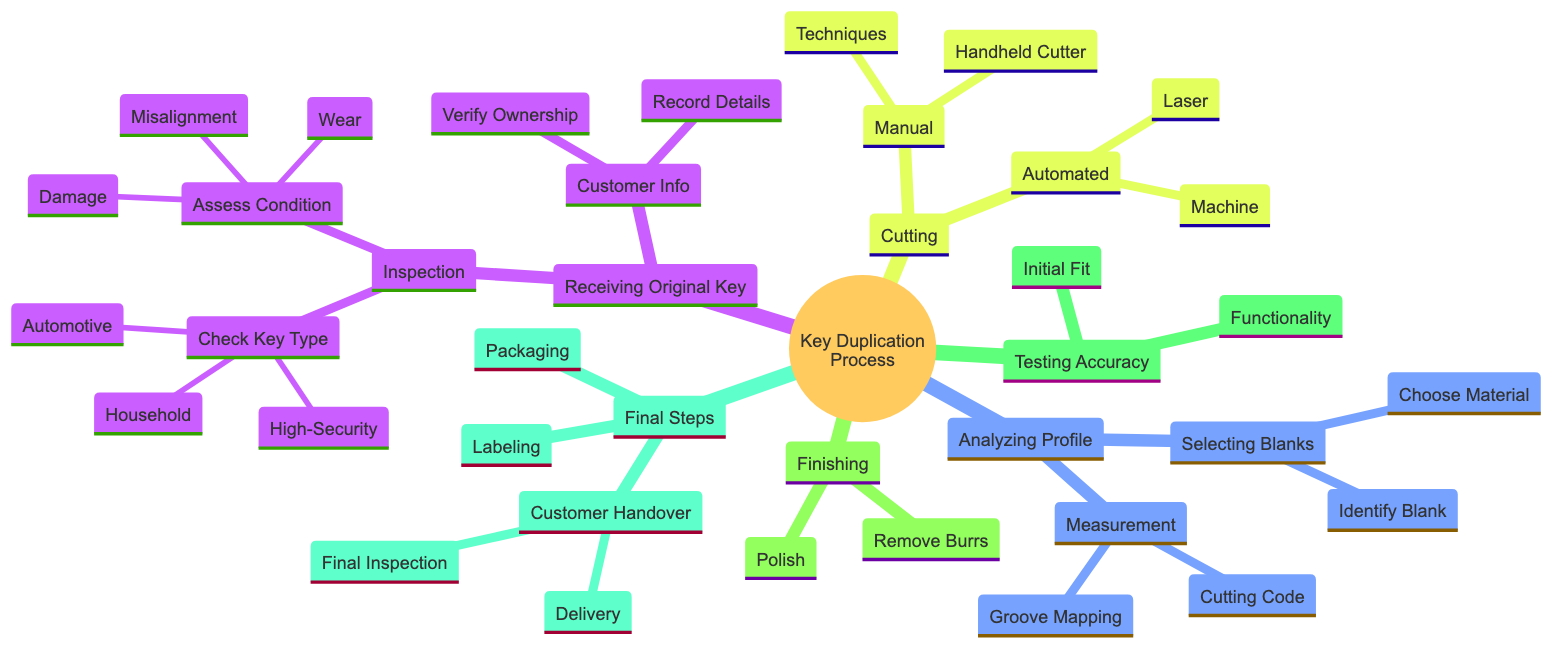What are the key types mentioned in the inspection process? The inspection process under "Receiving the Original Key" includes checking for different key types: Household, Automotive, and High-Security. These are explicitly listed as part of the "Check Key Type" node.
Answer: Household, Automotive, High-Security How many main phases are there in the Key Duplication Process? The diagram lists six main phases: Receiving the Original Key, Analyzing Key Profile, Cutting, Finishing and Polishing, Testing Key Accuracy, and Final Steps, indicating the major steps involved.
Answer: 6 What is the primary purpose of the 'Testing Key Accuracy' stage? The 'Testing Key Accuracy' stage includes two specific tests: Initial Fit and Functionality tests to ensure the duplicated key works properly within the lock. The key purpose is to validate the accuracy of the duplicated key.
Answer: Validate accuracy What materials can be selected from the 'Selecting Material' node? Under 'Selecting Blanks', the 'Selecting Material' node lists Brass, Steel, and Nickel-Silver as the materials from which blanks can be chosen for key duplication.
Answer: Brass, Steel, Nickel-Silver In the 'Cutting' phase, which process can be performed manually? The 'Manual Cutting' sub-phase includes using a Handheld Key Cutter and specific techniques such as Impressioning and Code Cutting, which are methods of cutting the key manually.
Answer: Handheld Key Cutter Which step occurs immediately after 'Finishing and Polishing'? The diagram indicates that the step following 'Finishing and Polishing' is 'Testing Key Accuracy', showing the sequential flow of the key duplication process from one phase to the next.
Answer: Testing Key Accuracy What is required during the 'Customer Information' phase? The 'Customer Information' phase requires two actions: Record Owner Details and Verify Ownership, ensuring that customer data is correctly recorded and ownership of the key is verified.
Answer: Record Owner Details, Verify Ownership How do you perform an Initial Fit Test? The Initial Fit Test involves inserting the duplicated key into the lock and checking for smooth operation. This step is essential to confirm that the key fits properly without any issues.
Answer: Inserting in Lock, Smooth Operation What does the 'Final Steps' phase include regarding customer interaction? During the 'Final Steps' phase, customer interaction is managed through two main actions: Final Inspection to confirm key quality and Delivery of the key, highlighting the importance of customer satisfaction at the end of the process.
Answer: Final Inspection, Delivery 